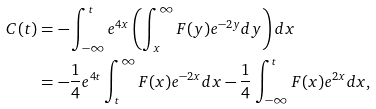<formula> <loc_0><loc_0><loc_500><loc_500>C ( t ) & = - \int _ { - \infty } ^ { t } e ^ { 4 x } \left ( \int _ { x } ^ { \infty } F ( y ) e ^ { - 2 y } d y \right ) d x \\ & = - \frac { 1 } { 4 } e ^ { 4 t } \int _ { t } ^ { \infty } F ( x ) e ^ { - 2 x } d x - \frac { 1 } { 4 } \int _ { - \infty } ^ { t } F ( x ) e ^ { 2 x } d x ,</formula> 